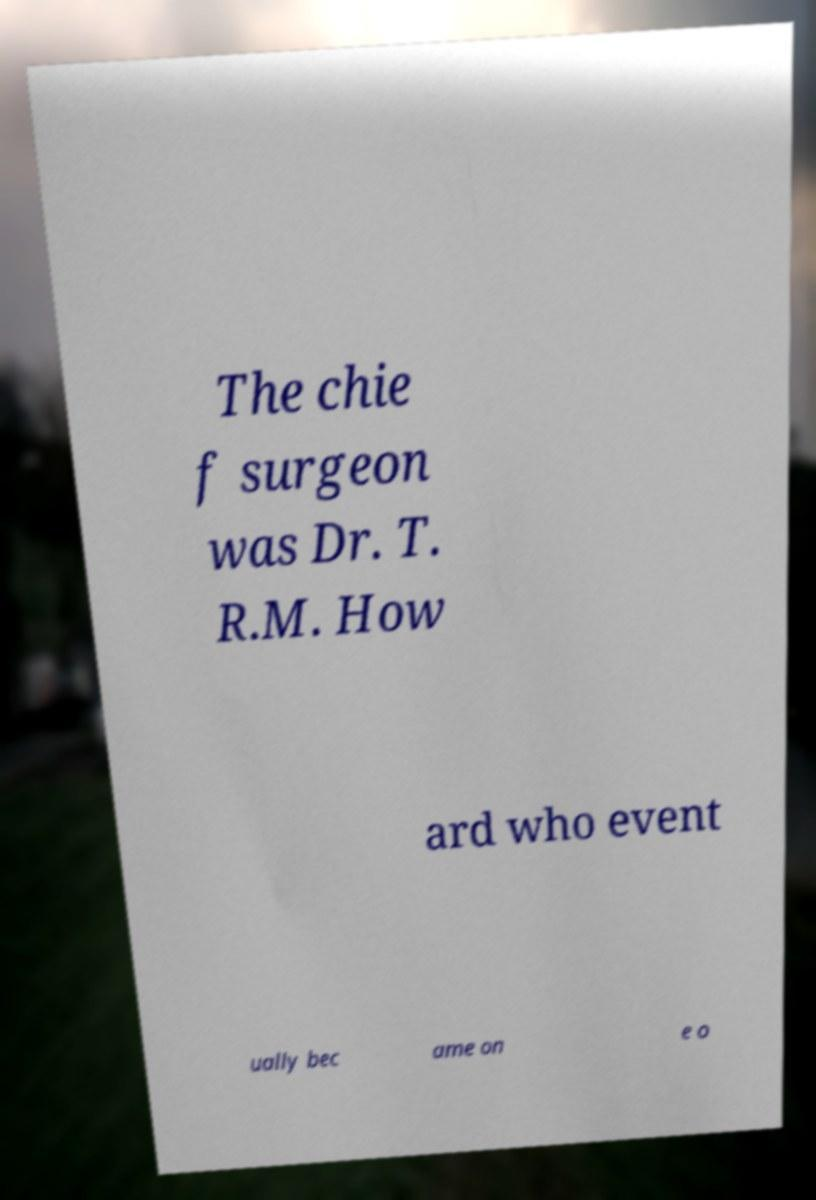Please read and relay the text visible in this image. What does it say? The chie f surgeon was Dr. T. R.M. How ard who event ually bec ame on e o 